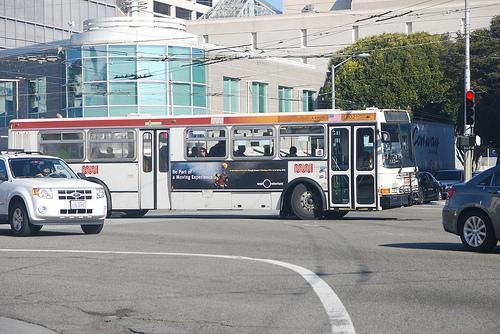How many cars are on the near side of the bus?
Give a very brief answer. 2. How many window panels on the front door?
Give a very brief answer. 4. How many vehicles are turning in the photo?
Give a very brief answer. 3. How many stories does the building behind the bus appear to have?
Give a very brief answer. 2. 